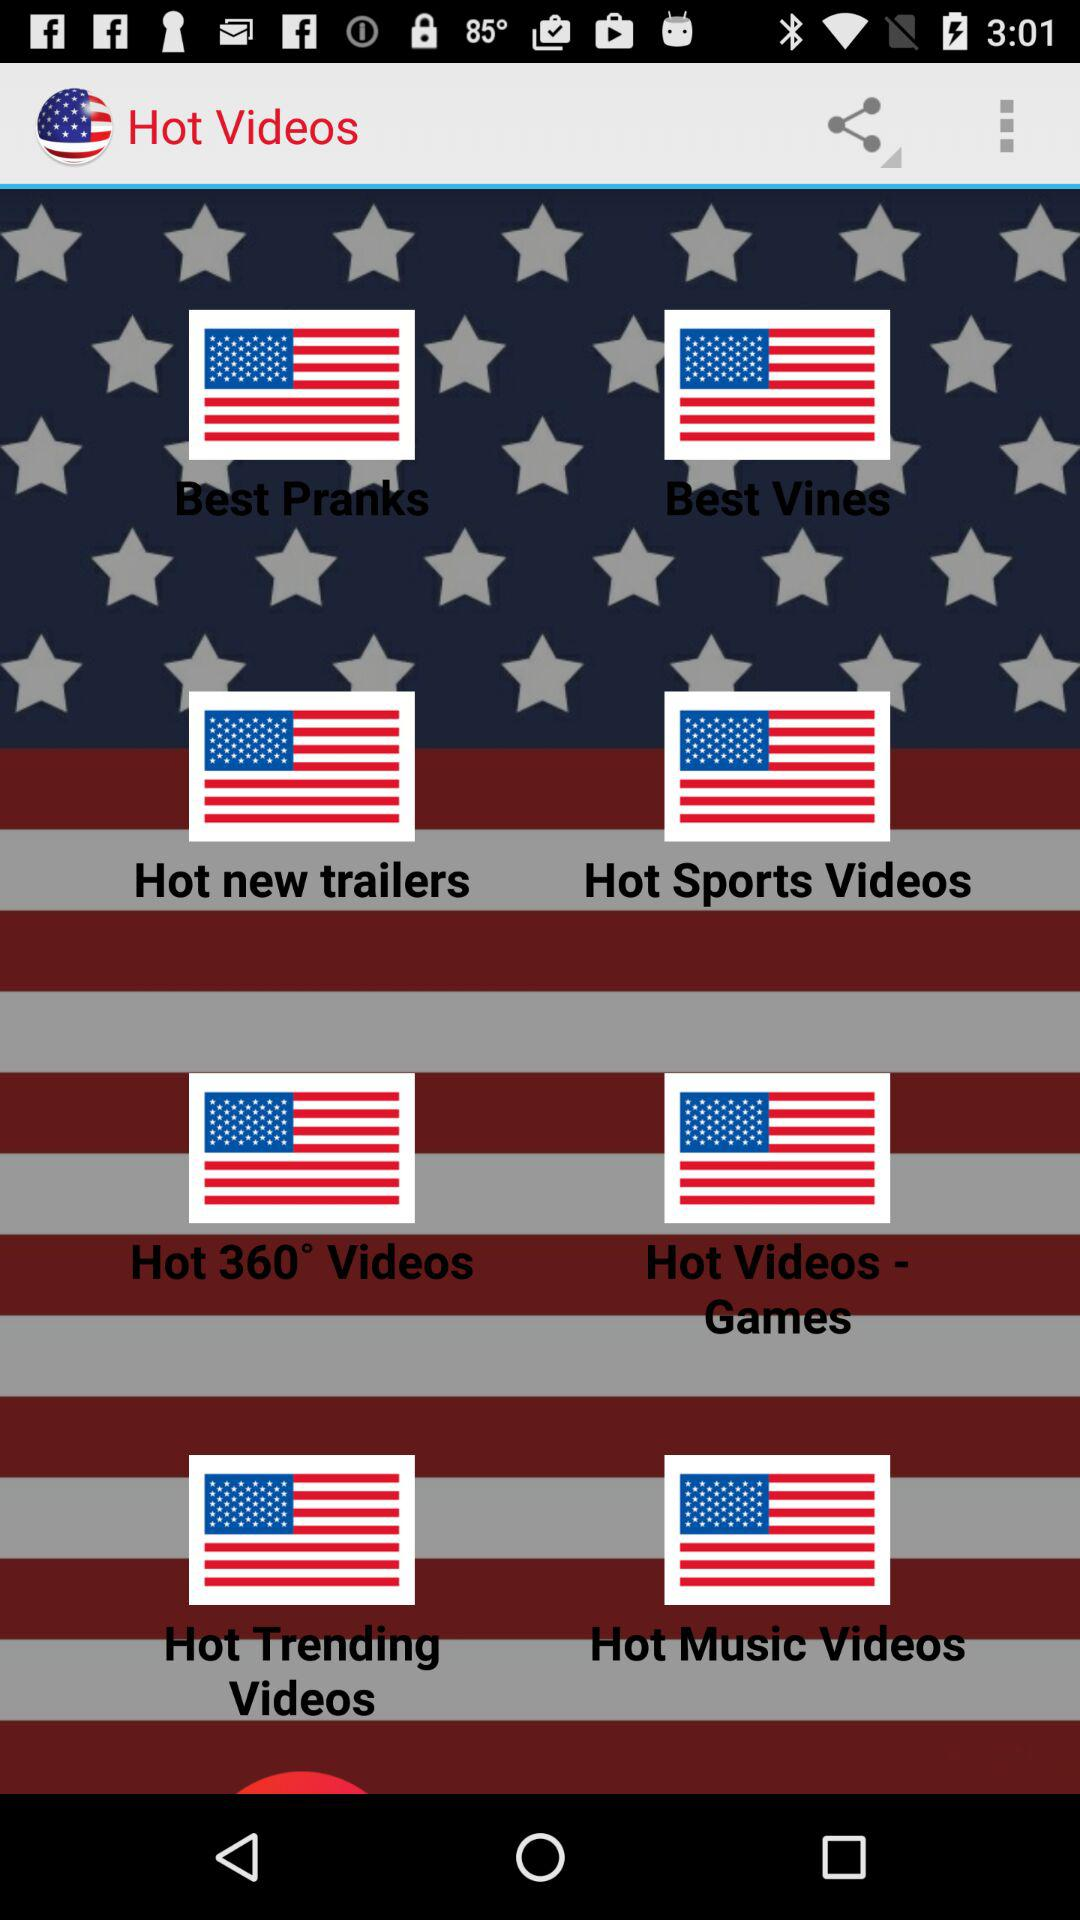What are the categories of "Hot Videos"? The categories are "Best Pranks", "Best Vines", "Hot new trailers", "Hot Sports Videos", "Hot 360° Videos", "Hot Videos - Games", "Hot Trending Videos" and "Hot Music Videos". 